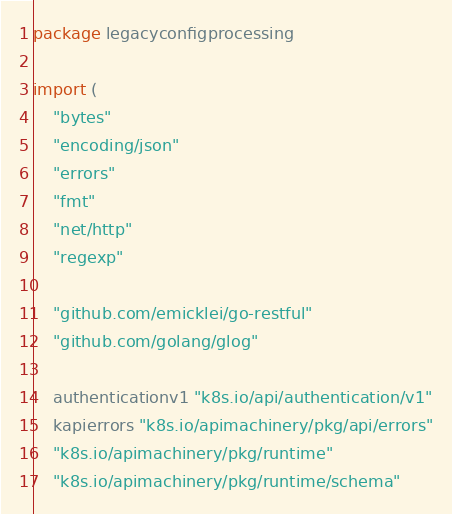<code> <loc_0><loc_0><loc_500><loc_500><_Go_>package legacyconfigprocessing

import (
	"bytes"
	"encoding/json"
	"errors"
	"fmt"
	"net/http"
	"regexp"

	"github.com/emicklei/go-restful"
	"github.com/golang/glog"

	authenticationv1 "k8s.io/api/authentication/v1"
	kapierrors "k8s.io/apimachinery/pkg/api/errors"
	"k8s.io/apimachinery/pkg/runtime"
	"k8s.io/apimachinery/pkg/runtime/schema"</code> 